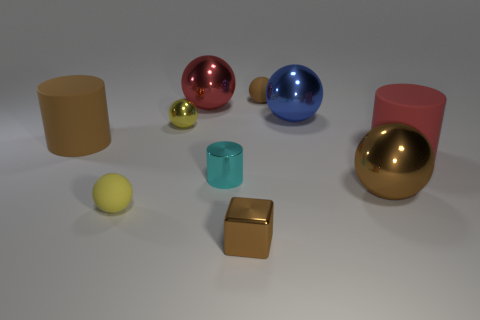What is the small cube made of?
Provide a short and direct response. Metal. What is the color of the large metal sphere left of the big blue metallic sphere?
Your answer should be compact. Red. What number of big things are cylinders or red cylinders?
Keep it short and to the point. 2. Is the color of the large rubber cylinder on the left side of the large blue metal object the same as the tiny matte ball that is on the right side of the small yellow metallic ball?
Your answer should be compact. Yes. What number of other objects are there of the same color as the metallic cube?
Your response must be concise. 3. How many gray objects are spheres or big matte things?
Give a very brief answer. 0. There is a big blue thing; is its shape the same as the matte thing that is in front of the red rubber cylinder?
Your answer should be very brief. Yes. What is the shape of the yellow metal object?
Ensure brevity in your answer.  Sphere. What is the material of the cyan cylinder that is the same size as the metallic block?
Offer a very short reply. Metal. How many objects are large red things or tiny matte objects behind the tiny yellow rubber object?
Make the answer very short. 3. 